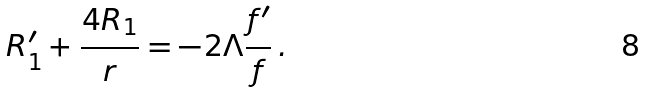Convert formula to latex. <formula><loc_0><loc_0><loc_500><loc_500>R ^ { \prime } _ { 1 } + \frac { 4 R _ { 1 } } { r } = - 2 \Lambda \frac { f ^ { \prime } } { f } \, .</formula> 